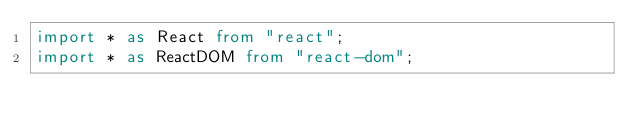Convert code to text. <code><loc_0><loc_0><loc_500><loc_500><_TypeScript_>import * as React from "react";
import * as ReactDOM from "react-dom";
</code> 